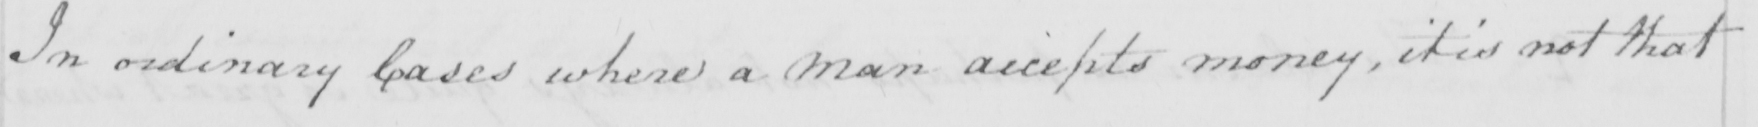What does this handwritten line say? In ordinary Cases where a man accepts money , it is not that 